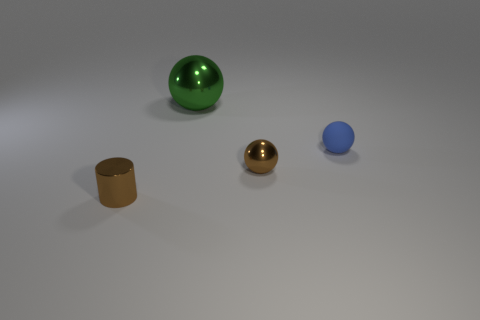Is there any other thing that is made of the same material as the tiny blue object?
Your answer should be very brief. No. Is the number of blue rubber spheres that are left of the large green shiny object less than the number of balls on the right side of the brown cylinder?
Keep it short and to the point. Yes. There is a metallic object behind the blue object; is its size the same as the small brown metallic ball?
Offer a terse response. No. There is a rubber thing right of the tiny brown ball; what is its shape?
Make the answer very short. Sphere. Are there more big red metal spheres than brown shiny things?
Your response must be concise. No. There is a small cylinder that is left of the large green object; is its color the same as the tiny metallic ball?
Keep it short and to the point. Yes. What number of objects are blue matte balls right of the brown ball or shiny things behind the brown cylinder?
Provide a succinct answer. 3. What number of objects are both right of the tiny brown cylinder and in front of the small blue object?
Offer a very short reply. 1. Is the brown cylinder made of the same material as the tiny brown ball?
Your answer should be compact. Yes. What shape is the small brown shiny object in front of the small shiny object that is behind the thing that is on the left side of the green sphere?
Your answer should be very brief. Cylinder. 